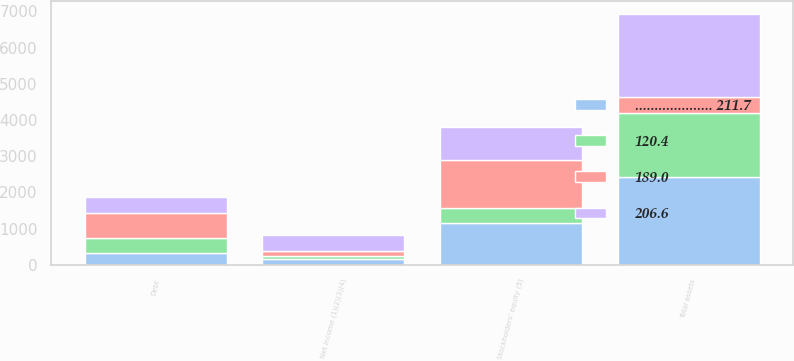Convert chart. <chart><loc_0><loc_0><loc_500><loc_500><stacked_bar_chart><ecel><fcel>Net income (1)(2)(3)(4)<fcel>Total assets<fcel>Debt<fcel>Stockholders' equity (5)<nl><fcel>189.0<fcel>158.9<fcel>447<fcel>691.2<fcel>1333.6<nl><fcel>.................... 211.7<fcel>164.2<fcel>2428.6<fcel>324.8<fcel>1156.1<nl><fcel>206.6<fcel>439.9<fcel>2287<fcel>447<fcel>915.2<nl><fcel>120.4<fcel>72.2<fcel>1761.3<fcel>426<fcel>411.1<nl></chart> 